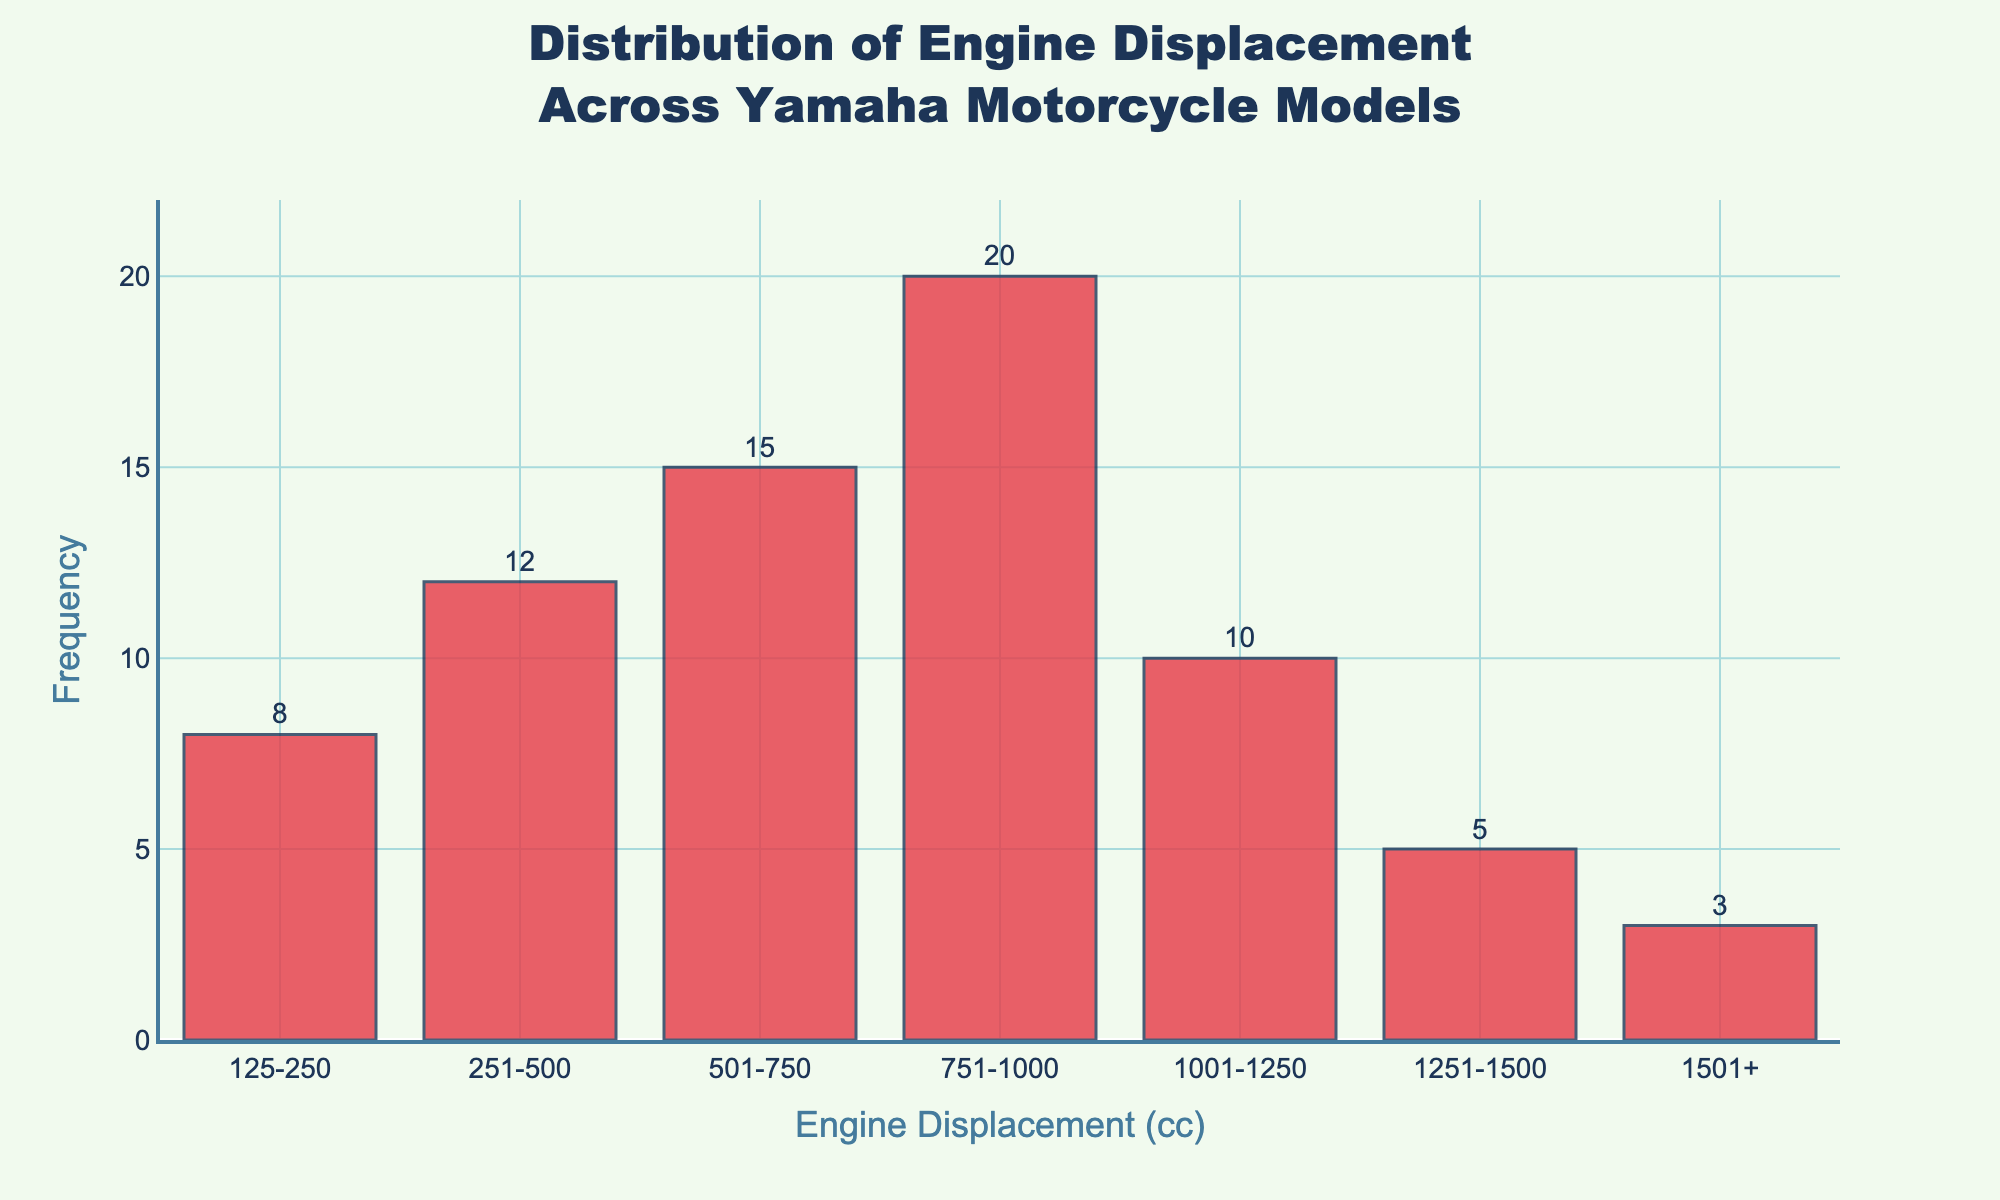What is the title of the figure? The title of the figure is displayed at the top in a larger font compared to the rest of the text. It reads "Distribution of Engine Displacement Across Yamaha Motorcycle Models".
Answer: Distribution of Engine Displacement Across Yamaha Motorcycle Models What is the most frequent range of engine displacement? To determine the most frequent range, look for the tallest bar in the histogram. The tallest bar corresponds to the engine displacement range of 751-1000 cc.
Answer: 751-1000 cc How many engine displacement ranges have a frequency greater than 10? There are 3 engine displacement ranges with a frequency greater than 10: 251-500, 501-750, and 751-1000 cc.
Answer: 3 What is the total frequency of engine displacements less than 500 cc? Sum the frequencies of the engine displacement ranges 125-250 and 251-500 cc. The frequencies are 8 and 12, respectively. 8 + 12 = 20.
Answer: 20 Which range has the lowest frequency and what is its value? The shortest bar corresponds to the range with the lowest frequency. The range 1501+ cc has the lowest frequency with a value of 3.
Answer: 1501+ cc, 3 How does the frequency of the 1001-1250 cc range compare to the 1251-1500 cc range? Look at both bars and note their frequencies. The 1001-1250 cc range has a frequency of 10, while the 1251-1500 cc range has a frequency of 5. The former is twice as frequent as the latter.
Answer: The 1001-1250 cc range is twice as frequent What's the combined frequency of engine displacements from 751-1250 cc? Sum the frequencies of the 751-1000 cc, and 1001-1250 cc ranges. Their frequencies are 20 and 10, respectively. 20 + 10 = 30.
Answer: 30 Is the distribution skewed towards smaller or larger engine displacements? Most of the frequencies are higher towards the left side of the histogram (smaller engine displacements), and they decrease as you move to the right. This suggests that the distribution is skewed towards smaller engine displacements.
Answer: Smaller engine displacements 